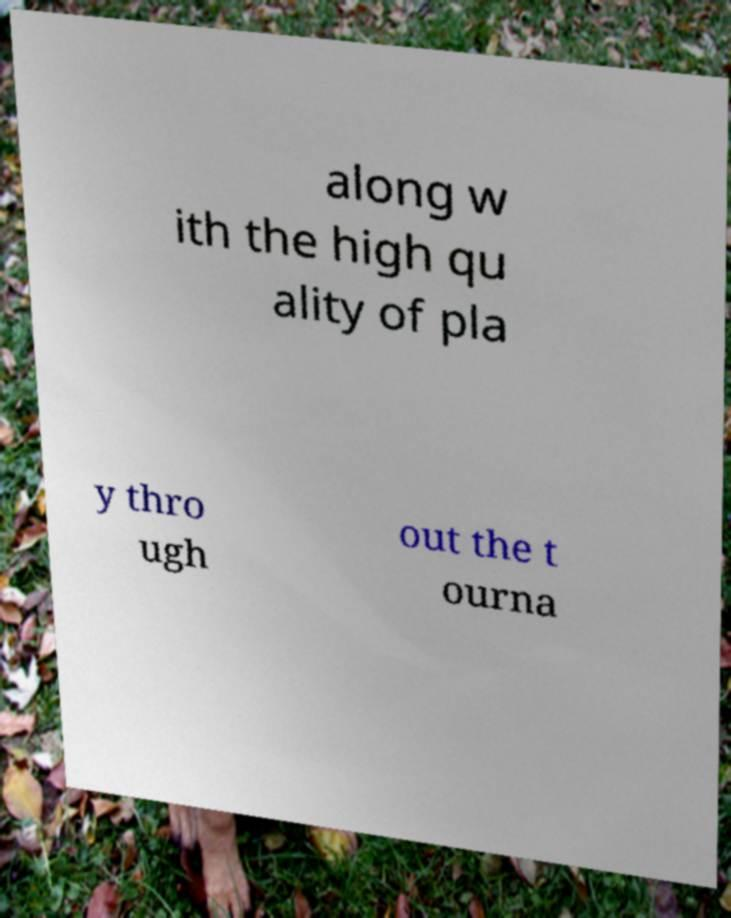Can you accurately transcribe the text from the provided image for me? along w ith the high qu ality of pla y thro ugh out the t ourna 